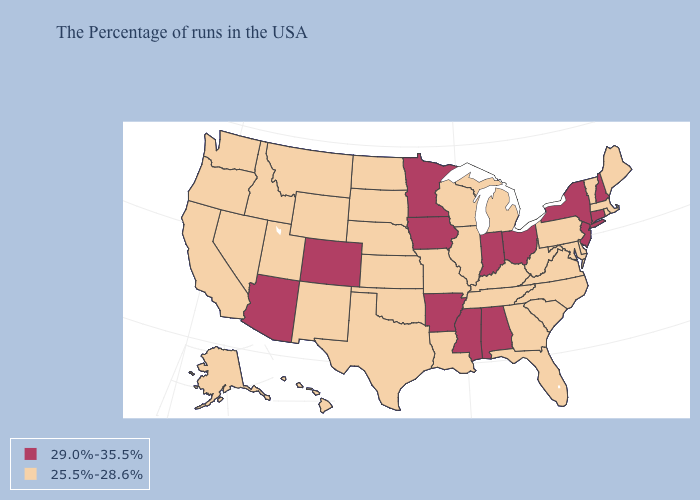Is the legend a continuous bar?
Concise answer only. No. What is the value of South Dakota?
Quick response, please. 25.5%-28.6%. Does Oklahoma have the same value as Nevada?
Quick response, please. Yes. What is the value of Vermont?
Concise answer only. 25.5%-28.6%. Among the states that border Wyoming , does Nebraska have the highest value?
Keep it brief. No. What is the lowest value in the Northeast?
Be succinct. 25.5%-28.6%. What is the value of New York?
Write a very short answer. 29.0%-35.5%. Does Texas have the same value as New York?
Keep it brief. No. Does Alabama have the lowest value in the South?
Short answer required. No. Does Missouri have a lower value than Colorado?
Be succinct. Yes. What is the value of Missouri?
Be succinct. 25.5%-28.6%. Name the states that have a value in the range 29.0%-35.5%?
Write a very short answer. New Hampshire, Connecticut, New York, New Jersey, Ohio, Indiana, Alabama, Mississippi, Arkansas, Minnesota, Iowa, Colorado, Arizona. What is the value of North Carolina?
Concise answer only. 25.5%-28.6%. Which states have the highest value in the USA?
Be succinct. New Hampshire, Connecticut, New York, New Jersey, Ohio, Indiana, Alabama, Mississippi, Arkansas, Minnesota, Iowa, Colorado, Arizona. Which states have the highest value in the USA?
Write a very short answer. New Hampshire, Connecticut, New York, New Jersey, Ohio, Indiana, Alabama, Mississippi, Arkansas, Minnesota, Iowa, Colorado, Arizona. 